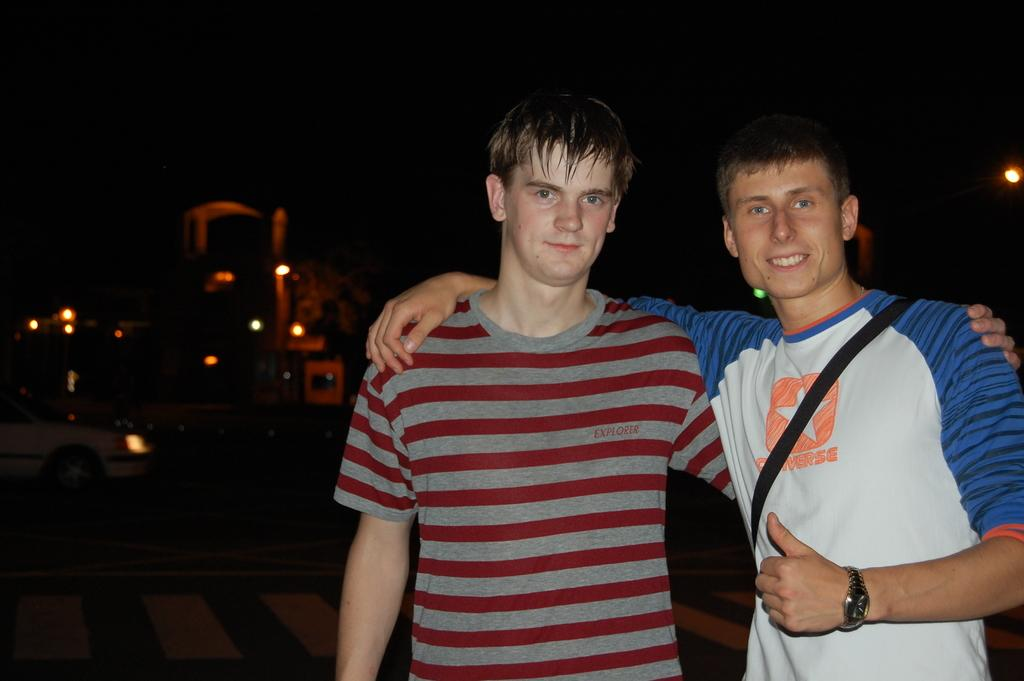<image>
Relay a brief, clear account of the picture shown. Two men have their arms around each other and one is wearing a shirt that says Converse. 